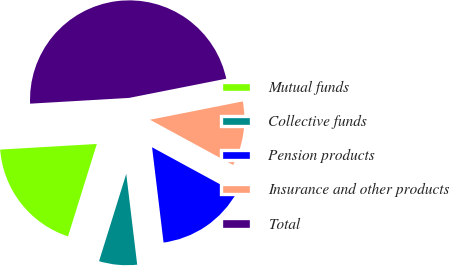<chart> <loc_0><loc_0><loc_500><loc_500><pie_chart><fcel>Mutual funds<fcel>Collective funds<fcel>Pension products<fcel>Insurance and other products<fcel>Total<nl><fcel>19.27%<fcel>6.72%<fcel>15.16%<fcel>11.04%<fcel>47.82%<nl></chart> 